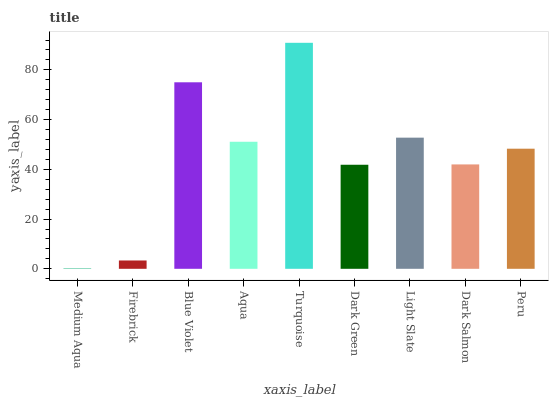Is Medium Aqua the minimum?
Answer yes or no. Yes. Is Turquoise the maximum?
Answer yes or no. Yes. Is Firebrick the minimum?
Answer yes or no. No. Is Firebrick the maximum?
Answer yes or no. No. Is Firebrick greater than Medium Aqua?
Answer yes or no. Yes. Is Medium Aqua less than Firebrick?
Answer yes or no. Yes. Is Medium Aqua greater than Firebrick?
Answer yes or no. No. Is Firebrick less than Medium Aqua?
Answer yes or no. No. Is Peru the high median?
Answer yes or no. Yes. Is Peru the low median?
Answer yes or no. Yes. Is Aqua the high median?
Answer yes or no. No. Is Turquoise the low median?
Answer yes or no. No. 